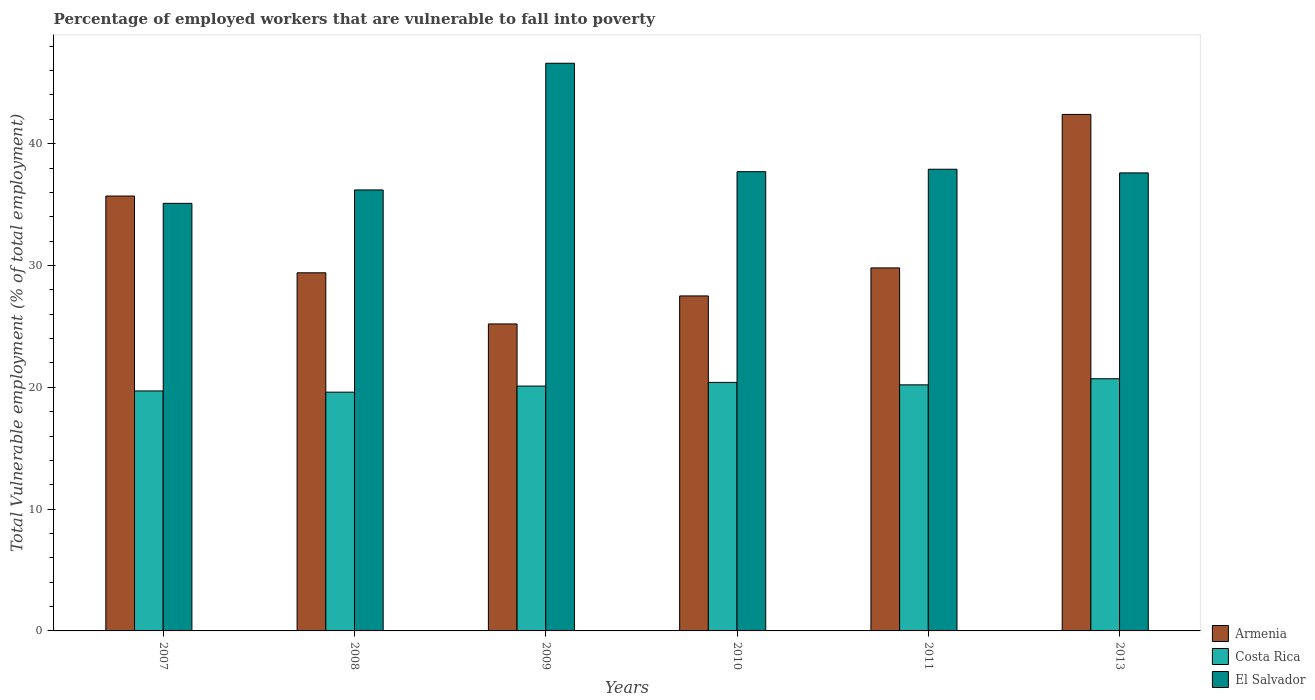How many different coloured bars are there?
Offer a very short reply. 3. Are the number of bars per tick equal to the number of legend labels?
Provide a short and direct response. Yes. How many bars are there on the 5th tick from the left?
Your response must be concise. 3. What is the label of the 3rd group of bars from the left?
Provide a succinct answer. 2009. In how many cases, is the number of bars for a given year not equal to the number of legend labels?
Your answer should be compact. 0. Across all years, what is the maximum percentage of employed workers who are vulnerable to fall into poverty in Costa Rica?
Make the answer very short. 20.7. Across all years, what is the minimum percentage of employed workers who are vulnerable to fall into poverty in El Salvador?
Keep it short and to the point. 35.1. In which year was the percentage of employed workers who are vulnerable to fall into poverty in Costa Rica maximum?
Your response must be concise. 2013. In which year was the percentage of employed workers who are vulnerable to fall into poverty in El Salvador minimum?
Your answer should be very brief. 2007. What is the total percentage of employed workers who are vulnerable to fall into poverty in El Salvador in the graph?
Your answer should be compact. 231.1. What is the difference between the percentage of employed workers who are vulnerable to fall into poverty in Armenia in 2008 and that in 2010?
Your response must be concise. 1.9. What is the difference between the percentage of employed workers who are vulnerable to fall into poverty in Costa Rica in 2010 and the percentage of employed workers who are vulnerable to fall into poverty in Armenia in 2013?
Provide a succinct answer. -22. What is the average percentage of employed workers who are vulnerable to fall into poverty in Armenia per year?
Make the answer very short. 31.67. In the year 2007, what is the difference between the percentage of employed workers who are vulnerable to fall into poverty in Armenia and percentage of employed workers who are vulnerable to fall into poverty in El Salvador?
Offer a terse response. 0.6. What is the ratio of the percentage of employed workers who are vulnerable to fall into poverty in El Salvador in 2008 to that in 2010?
Make the answer very short. 0.96. Is the difference between the percentage of employed workers who are vulnerable to fall into poverty in Armenia in 2008 and 2010 greater than the difference between the percentage of employed workers who are vulnerable to fall into poverty in El Salvador in 2008 and 2010?
Ensure brevity in your answer.  Yes. What is the difference between the highest and the second highest percentage of employed workers who are vulnerable to fall into poverty in El Salvador?
Keep it short and to the point. 8.7. What is the difference between the highest and the lowest percentage of employed workers who are vulnerable to fall into poverty in El Salvador?
Your response must be concise. 11.5. What does the 3rd bar from the left in 2013 represents?
Your answer should be very brief. El Salvador. What does the 1st bar from the right in 2010 represents?
Give a very brief answer. El Salvador. Are all the bars in the graph horizontal?
Provide a succinct answer. No. Does the graph contain any zero values?
Offer a terse response. No. Where does the legend appear in the graph?
Keep it short and to the point. Bottom right. What is the title of the graph?
Make the answer very short. Percentage of employed workers that are vulnerable to fall into poverty. What is the label or title of the Y-axis?
Your answer should be very brief. Total Vulnerable employment (% of total employment). What is the Total Vulnerable employment (% of total employment) in Armenia in 2007?
Your answer should be compact. 35.7. What is the Total Vulnerable employment (% of total employment) of Costa Rica in 2007?
Your response must be concise. 19.7. What is the Total Vulnerable employment (% of total employment) in El Salvador in 2007?
Make the answer very short. 35.1. What is the Total Vulnerable employment (% of total employment) of Armenia in 2008?
Your answer should be compact. 29.4. What is the Total Vulnerable employment (% of total employment) in Costa Rica in 2008?
Offer a terse response. 19.6. What is the Total Vulnerable employment (% of total employment) in El Salvador in 2008?
Keep it short and to the point. 36.2. What is the Total Vulnerable employment (% of total employment) in Armenia in 2009?
Make the answer very short. 25.2. What is the Total Vulnerable employment (% of total employment) in Costa Rica in 2009?
Ensure brevity in your answer.  20.1. What is the Total Vulnerable employment (% of total employment) of El Salvador in 2009?
Ensure brevity in your answer.  46.6. What is the Total Vulnerable employment (% of total employment) in Costa Rica in 2010?
Your answer should be compact. 20.4. What is the Total Vulnerable employment (% of total employment) in El Salvador in 2010?
Keep it short and to the point. 37.7. What is the Total Vulnerable employment (% of total employment) of Armenia in 2011?
Offer a terse response. 29.8. What is the Total Vulnerable employment (% of total employment) in Costa Rica in 2011?
Keep it short and to the point. 20.2. What is the Total Vulnerable employment (% of total employment) of El Salvador in 2011?
Offer a terse response. 37.9. What is the Total Vulnerable employment (% of total employment) of Armenia in 2013?
Provide a succinct answer. 42.4. What is the Total Vulnerable employment (% of total employment) in Costa Rica in 2013?
Your answer should be very brief. 20.7. What is the Total Vulnerable employment (% of total employment) in El Salvador in 2013?
Give a very brief answer. 37.6. Across all years, what is the maximum Total Vulnerable employment (% of total employment) in Armenia?
Your answer should be very brief. 42.4. Across all years, what is the maximum Total Vulnerable employment (% of total employment) in Costa Rica?
Provide a succinct answer. 20.7. Across all years, what is the maximum Total Vulnerable employment (% of total employment) in El Salvador?
Ensure brevity in your answer.  46.6. Across all years, what is the minimum Total Vulnerable employment (% of total employment) of Armenia?
Provide a short and direct response. 25.2. Across all years, what is the minimum Total Vulnerable employment (% of total employment) of Costa Rica?
Your response must be concise. 19.6. Across all years, what is the minimum Total Vulnerable employment (% of total employment) of El Salvador?
Ensure brevity in your answer.  35.1. What is the total Total Vulnerable employment (% of total employment) of Armenia in the graph?
Your answer should be compact. 190. What is the total Total Vulnerable employment (% of total employment) in Costa Rica in the graph?
Offer a terse response. 120.7. What is the total Total Vulnerable employment (% of total employment) in El Salvador in the graph?
Your answer should be compact. 231.1. What is the difference between the Total Vulnerable employment (% of total employment) of Costa Rica in 2007 and that in 2008?
Your response must be concise. 0.1. What is the difference between the Total Vulnerable employment (% of total employment) of El Salvador in 2007 and that in 2008?
Make the answer very short. -1.1. What is the difference between the Total Vulnerable employment (% of total employment) in El Salvador in 2007 and that in 2009?
Give a very brief answer. -11.5. What is the difference between the Total Vulnerable employment (% of total employment) in Armenia in 2007 and that in 2010?
Provide a short and direct response. 8.2. What is the difference between the Total Vulnerable employment (% of total employment) of Costa Rica in 2007 and that in 2010?
Give a very brief answer. -0.7. What is the difference between the Total Vulnerable employment (% of total employment) in El Salvador in 2007 and that in 2010?
Ensure brevity in your answer.  -2.6. What is the difference between the Total Vulnerable employment (% of total employment) of Costa Rica in 2007 and that in 2011?
Ensure brevity in your answer.  -0.5. What is the difference between the Total Vulnerable employment (% of total employment) of Costa Rica in 2007 and that in 2013?
Offer a very short reply. -1. What is the difference between the Total Vulnerable employment (% of total employment) in El Salvador in 2008 and that in 2009?
Keep it short and to the point. -10.4. What is the difference between the Total Vulnerable employment (% of total employment) of El Salvador in 2008 and that in 2010?
Ensure brevity in your answer.  -1.5. What is the difference between the Total Vulnerable employment (% of total employment) of Costa Rica in 2008 and that in 2011?
Provide a succinct answer. -0.6. What is the difference between the Total Vulnerable employment (% of total employment) in Costa Rica in 2008 and that in 2013?
Make the answer very short. -1.1. What is the difference between the Total Vulnerable employment (% of total employment) in Armenia in 2009 and that in 2011?
Your answer should be compact. -4.6. What is the difference between the Total Vulnerable employment (% of total employment) of Armenia in 2009 and that in 2013?
Provide a short and direct response. -17.2. What is the difference between the Total Vulnerable employment (% of total employment) in Costa Rica in 2009 and that in 2013?
Give a very brief answer. -0.6. What is the difference between the Total Vulnerable employment (% of total employment) in El Salvador in 2009 and that in 2013?
Make the answer very short. 9. What is the difference between the Total Vulnerable employment (% of total employment) of Armenia in 2010 and that in 2011?
Ensure brevity in your answer.  -2.3. What is the difference between the Total Vulnerable employment (% of total employment) of Costa Rica in 2010 and that in 2011?
Offer a very short reply. 0.2. What is the difference between the Total Vulnerable employment (% of total employment) of El Salvador in 2010 and that in 2011?
Offer a very short reply. -0.2. What is the difference between the Total Vulnerable employment (% of total employment) in Armenia in 2010 and that in 2013?
Offer a terse response. -14.9. What is the difference between the Total Vulnerable employment (% of total employment) in Armenia in 2007 and the Total Vulnerable employment (% of total employment) in Costa Rica in 2008?
Provide a succinct answer. 16.1. What is the difference between the Total Vulnerable employment (% of total employment) of Costa Rica in 2007 and the Total Vulnerable employment (% of total employment) of El Salvador in 2008?
Offer a very short reply. -16.5. What is the difference between the Total Vulnerable employment (% of total employment) in Costa Rica in 2007 and the Total Vulnerable employment (% of total employment) in El Salvador in 2009?
Offer a very short reply. -26.9. What is the difference between the Total Vulnerable employment (% of total employment) of Costa Rica in 2007 and the Total Vulnerable employment (% of total employment) of El Salvador in 2010?
Keep it short and to the point. -18. What is the difference between the Total Vulnerable employment (% of total employment) in Armenia in 2007 and the Total Vulnerable employment (% of total employment) in Costa Rica in 2011?
Offer a very short reply. 15.5. What is the difference between the Total Vulnerable employment (% of total employment) of Armenia in 2007 and the Total Vulnerable employment (% of total employment) of El Salvador in 2011?
Provide a short and direct response. -2.2. What is the difference between the Total Vulnerable employment (% of total employment) in Costa Rica in 2007 and the Total Vulnerable employment (% of total employment) in El Salvador in 2011?
Your answer should be compact. -18.2. What is the difference between the Total Vulnerable employment (% of total employment) in Armenia in 2007 and the Total Vulnerable employment (% of total employment) in Costa Rica in 2013?
Offer a terse response. 15. What is the difference between the Total Vulnerable employment (% of total employment) in Armenia in 2007 and the Total Vulnerable employment (% of total employment) in El Salvador in 2013?
Make the answer very short. -1.9. What is the difference between the Total Vulnerable employment (% of total employment) of Costa Rica in 2007 and the Total Vulnerable employment (% of total employment) of El Salvador in 2013?
Make the answer very short. -17.9. What is the difference between the Total Vulnerable employment (% of total employment) in Armenia in 2008 and the Total Vulnerable employment (% of total employment) in Costa Rica in 2009?
Your response must be concise. 9.3. What is the difference between the Total Vulnerable employment (% of total employment) of Armenia in 2008 and the Total Vulnerable employment (% of total employment) of El Salvador in 2009?
Your answer should be compact. -17.2. What is the difference between the Total Vulnerable employment (% of total employment) of Armenia in 2008 and the Total Vulnerable employment (% of total employment) of Costa Rica in 2010?
Your response must be concise. 9. What is the difference between the Total Vulnerable employment (% of total employment) of Costa Rica in 2008 and the Total Vulnerable employment (% of total employment) of El Salvador in 2010?
Offer a terse response. -18.1. What is the difference between the Total Vulnerable employment (% of total employment) of Armenia in 2008 and the Total Vulnerable employment (% of total employment) of El Salvador in 2011?
Ensure brevity in your answer.  -8.5. What is the difference between the Total Vulnerable employment (% of total employment) in Costa Rica in 2008 and the Total Vulnerable employment (% of total employment) in El Salvador in 2011?
Make the answer very short. -18.3. What is the difference between the Total Vulnerable employment (% of total employment) in Armenia in 2008 and the Total Vulnerable employment (% of total employment) in Costa Rica in 2013?
Your answer should be very brief. 8.7. What is the difference between the Total Vulnerable employment (% of total employment) of Armenia in 2008 and the Total Vulnerable employment (% of total employment) of El Salvador in 2013?
Offer a terse response. -8.2. What is the difference between the Total Vulnerable employment (% of total employment) in Armenia in 2009 and the Total Vulnerable employment (% of total employment) in Costa Rica in 2010?
Provide a succinct answer. 4.8. What is the difference between the Total Vulnerable employment (% of total employment) of Costa Rica in 2009 and the Total Vulnerable employment (% of total employment) of El Salvador in 2010?
Ensure brevity in your answer.  -17.6. What is the difference between the Total Vulnerable employment (% of total employment) in Armenia in 2009 and the Total Vulnerable employment (% of total employment) in Costa Rica in 2011?
Your response must be concise. 5. What is the difference between the Total Vulnerable employment (% of total employment) in Armenia in 2009 and the Total Vulnerable employment (% of total employment) in El Salvador in 2011?
Ensure brevity in your answer.  -12.7. What is the difference between the Total Vulnerable employment (% of total employment) in Costa Rica in 2009 and the Total Vulnerable employment (% of total employment) in El Salvador in 2011?
Offer a very short reply. -17.8. What is the difference between the Total Vulnerable employment (% of total employment) of Armenia in 2009 and the Total Vulnerable employment (% of total employment) of Costa Rica in 2013?
Ensure brevity in your answer.  4.5. What is the difference between the Total Vulnerable employment (% of total employment) in Costa Rica in 2009 and the Total Vulnerable employment (% of total employment) in El Salvador in 2013?
Give a very brief answer. -17.5. What is the difference between the Total Vulnerable employment (% of total employment) of Armenia in 2010 and the Total Vulnerable employment (% of total employment) of Costa Rica in 2011?
Make the answer very short. 7.3. What is the difference between the Total Vulnerable employment (% of total employment) of Costa Rica in 2010 and the Total Vulnerable employment (% of total employment) of El Salvador in 2011?
Offer a very short reply. -17.5. What is the difference between the Total Vulnerable employment (% of total employment) in Armenia in 2010 and the Total Vulnerable employment (% of total employment) in Costa Rica in 2013?
Give a very brief answer. 6.8. What is the difference between the Total Vulnerable employment (% of total employment) in Costa Rica in 2010 and the Total Vulnerable employment (% of total employment) in El Salvador in 2013?
Keep it short and to the point. -17.2. What is the difference between the Total Vulnerable employment (% of total employment) of Costa Rica in 2011 and the Total Vulnerable employment (% of total employment) of El Salvador in 2013?
Your answer should be very brief. -17.4. What is the average Total Vulnerable employment (% of total employment) of Armenia per year?
Your answer should be compact. 31.67. What is the average Total Vulnerable employment (% of total employment) of Costa Rica per year?
Ensure brevity in your answer.  20.12. What is the average Total Vulnerable employment (% of total employment) of El Salvador per year?
Your answer should be compact. 38.52. In the year 2007, what is the difference between the Total Vulnerable employment (% of total employment) in Armenia and Total Vulnerable employment (% of total employment) in Costa Rica?
Provide a short and direct response. 16. In the year 2007, what is the difference between the Total Vulnerable employment (% of total employment) of Armenia and Total Vulnerable employment (% of total employment) of El Salvador?
Offer a terse response. 0.6. In the year 2007, what is the difference between the Total Vulnerable employment (% of total employment) in Costa Rica and Total Vulnerable employment (% of total employment) in El Salvador?
Give a very brief answer. -15.4. In the year 2008, what is the difference between the Total Vulnerable employment (% of total employment) in Costa Rica and Total Vulnerable employment (% of total employment) in El Salvador?
Provide a succinct answer. -16.6. In the year 2009, what is the difference between the Total Vulnerable employment (% of total employment) in Armenia and Total Vulnerable employment (% of total employment) in Costa Rica?
Provide a succinct answer. 5.1. In the year 2009, what is the difference between the Total Vulnerable employment (% of total employment) of Armenia and Total Vulnerable employment (% of total employment) of El Salvador?
Give a very brief answer. -21.4. In the year 2009, what is the difference between the Total Vulnerable employment (% of total employment) of Costa Rica and Total Vulnerable employment (% of total employment) of El Salvador?
Provide a short and direct response. -26.5. In the year 2010, what is the difference between the Total Vulnerable employment (% of total employment) in Armenia and Total Vulnerable employment (% of total employment) in Costa Rica?
Make the answer very short. 7.1. In the year 2010, what is the difference between the Total Vulnerable employment (% of total employment) of Armenia and Total Vulnerable employment (% of total employment) of El Salvador?
Offer a very short reply. -10.2. In the year 2010, what is the difference between the Total Vulnerable employment (% of total employment) in Costa Rica and Total Vulnerable employment (% of total employment) in El Salvador?
Offer a terse response. -17.3. In the year 2011, what is the difference between the Total Vulnerable employment (% of total employment) in Armenia and Total Vulnerable employment (% of total employment) in El Salvador?
Your answer should be compact. -8.1. In the year 2011, what is the difference between the Total Vulnerable employment (% of total employment) in Costa Rica and Total Vulnerable employment (% of total employment) in El Salvador?
Your answer should be compact. -17.7. In the year 2013, what is the difference between the Total Vulnerable employment (% of total employment) in Armenia and Total Vulnerable employment (% of total employment) in Costa Rica?
Provide a succinct answer. 21.7. In the year 2013, what is the difference between the Total Vulnerable employment (% of total employment) of Armenia and Total Vulnerable employment (% of total employment) of El Salvador?
Give a very brief answer. 4.8. In the year 2013, what is the difference between the Total Vulnerable employment (% of total employment) of Costa Rica and Total Vulnerable employment (% of total employment) of El Salvador?
Offer a terse response. -16.9. What is the ratio of the Total Vulnerable employment (% of total employment) in Armenia in 2007 to that in 2008?
Offer a terse response. 1.21. What is the ratio of the Total Vulnerable employment (% of total employment) of El Salvador in 2007 to that in 2008?
Provide a succinct answer. 0.97. What is the ratio of the Total Vulnerable employment (% of total employment) in Armenia in 2007 to that in 2009?
Provide a succinct answer. 1.42. What is the ratio of the Total Vulnerable employment (% of total employment) of Costa Rica in 2007 to that in 2009?
Provide a short and direct response. 0.98. What is the ratio of the Total Vulnerable employment (% of total employment) of El Salvador in 2007 to that in 2009?
Your answer should be compact. 0.75. What is the ratio of the Total Vulnerable employment (% of total employment) in Armenia in 2007 to that in 2010?
Ensure brevity in your answer.  1.3. What is the ratio of the Total Vulnerable employment (% of total employment) of Costa Rica in 2007 to that in 2010?
Your answer should be very brief. 0.97. What is the ratio of the Total Vulnerable employment (% of total employment) in El Salvador in 2007 to that in 2010?
Offer a very short reply. 0.93. What is the ratio of the Total Vulnerable employment (% of total employment) of Armenia in 2007 to that in 2011?
Make the answer very short. 1.2. What is the ratio of the Total Vulnerable employment (% of total employment) in Costa Rica in 2007 to that in 2011?
Your answer should be very brief. 0.98. What is the ratio of the Total Vulnerable employment (% of total employment) in El Salvador in 2007 to that in 2011?
Ensure brevity in your answer.  0.93. What is the ratio of the Total Vulnerable employment (% of total employment) in Armenia in 2007 to that in 2013?
Ensure brevity in your answer.  0.84. What is the ratio of the Total Vulnerable employment (% of total employment) of Costa Rica in 2007 to that in 2013?
Make the answer very short. 0.95. What is the ratio of the Total Vulnerable employment (% of total employment) in El Salvador in 2007 to that in 2013?
Keep it short and to the point. 0.93. What is the ratio of the Total Vulnerable employment (% of total employment) in Armenia in 2008 to that in 2009?
Provide a short and direct response. 1.17. What is the ratio of the Total Vulnerable employment (% of total employment) in Costa Rica in 2008 to that in 2009?
Give a very brief answer. 0.98. What is the ratio of the Total Vulnerable employment (% of total employment) in El Salvador in 2008 to that in 2009?
Provide a succinct answer. 0.78. What is the ratio of the Total Vulnerable employment (% of total employment) of Armenia in 2008 to that in 2010?
Offer a very short reply. 1.07. What is the ratio of the Total Vulnerable employment (% of total employment) in Costa Rica in 2008 to that in 2010?
Make the answer very short. 0.96. What is the ratio of the Total Vulnerable employment (% of total employment) of El Salvador in 2008 to that in 2010?
Provide a succinct answer. 0.96. What is the ratio of the Total Vulnerable employment (% of total employment) in Armenia in 2008 to that in 2011?
Make the answer very short. 0.99. What is the ratio of the Total Vulnerable employment (% of total employment) in Costa Rica in 2008 to that in 2011?
Provide a succinct answer. 0.97. What is the ratio of the Total Vulnerable employment (% of total employment) of El Salvador in 2008 to that in 2011?
Your answer should be compact. 0.96. What is the ratio of the Total Vulnerable employment (% of total employment) in Armenia in 2008 to that in 2013?
Ensure brevity in your answer.  0.69. What is the ratio of the Total Vulnerable employment (% of total employment) of Costa Rica in 2008 to that in 2013?
Offer a terse response. 0.95. What is the ratio of the Total Vulnerable employment (% of total employment) in El Salvador in 2008 to that in 2013?
Ensure brevity in your answer.  0.96. What is the ratio of the Total Vulnerable employment (% of total employment) of Armenia in 2009 to that in 2010?
Make the answer very short. 0.92. What is the ratio of the Total Vulnerable employment (% of total employment) in Costa Rica in 2009 to that in 2010?
Your response must be concise. 0.99. What is the ratio of the Total Vulnerable employment (% of total employment) in El Salvador in 2009 to that in 2010?
Offer a terse response. 1.24. What is the ratio of the Total Vulnerable employment (% of total employment) of Armenia in 2009 to that in 2011?
Ensure brevity in your answer.  0.85. What is the ratio of the Total Vulnerable employment (% of total employment) in Costa Rica in 2009 to that in 2011?
Your answer should be compact. 0.99. What is the ratio of the Total Vulnerable employment (% of total employment) of El Salvador in 2009 to that in 2011?
Give a very brief answer. 1.23. What is the ratio of the Total Vulnerable employment (% of total employment) of Armenia in 2009 to that in 2013?
Provide a succinct answer. 0.59. What is the ratio of the Total Vulnerable employment (% of total employment) of El Salvador in 2009 to that in 2013?
Ensure brevity in your answer.  1.24. What is the ratio of the Total Vulnerable employment (% of total employment) of Armenia in 2010 to that in 2011?
Keep it short and to the point. 0.92. What is the ratio of the Total Vulnerable employment (% of total employment) of Costa Rica in 2010 to that in 2011?
Your answer should be compact. 1.01. What is the ratio of the Total Vulnerable employment (% of total employment) in Armenia in 2010 to that in 2013?
Offer a terse response. 0.65. What is the ratio of the Total Vulnerable employment (% of total employment) in Costa Rica in 2010 to that in 2013?
Your answer should be compact. 0.99. What is the ratio of the Total Vulnerable employment (% of total employment) of El Salvador in 2010 to that in 2013?
Your answer should be very brief. 1. What is the ratio of the Total Vulnerable employment (% of total employment) of Armenia in 2011 to that in 2013?
Ensure brevity in your answer.  0.7. What is the ratio of the Total Vulnerable employment (% of total employment) in Costa Rica in 2011 to that in 2013?
Offer a very short reply. 0.98. What is the difference between the highest and the second highest Total Vulnerable employment (% of total employment) in Armenia?
Offer a very short reply. 6.7. What is the difference between the highest and the second highest Total Vulnerable employment (% of total employment) of El Salvador?
Make the answer very short. 8.7. What is the difference between the highest and the lowest Total Vulnerable employment (% of total employment) of Costa Rica?
Keep it short and to the point. 1.1. 